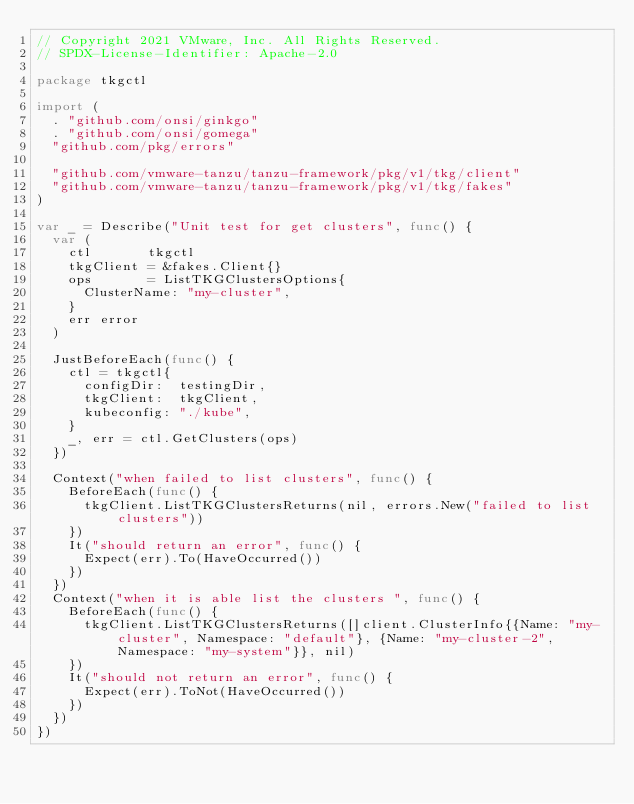<code> <loc_0><loc_0><loc_500><loc_500><_Go_>// Copyright 2021 VMware, Inc. All Rights Reserved.
// SPDX-License-Identifier: Apache-2.0

package tkgctl

import (
	. "github.com/onsi/ginkgo"
	. "github.com/onsi/gomega"
	"github.com/pkg/errors"

	"github.com/vmware-tanzu/tanzu-framework/pkg/v1/tkg/client"
	"github.com/vmware-tanzu/tanzu-framework/pkg/v1/tkg/fakes"
)

var _ = Describe("Unit test for get clusters", func() {
	var (
		ctl       tkgctl
		tkgClient = &fakes.Client{}
		ops       = ListTKGClustersOptions{
			ClusterName: "my-cluster",
		}
		err error
	)

	JustBeforeEach(func() {
		ctl = tkgctl{
			configDir:  testingDir,
			tkgClient:  tkgClient,
			kubeconfig: "./kube",
		}
		_, err = ctl.GetClusters(ops)
	})

	Context("when failed to list clusters", func() {
		BeforeEach(func() {
			tkgClient.ListTKGClustersReturns(nil, errors.New("failed to list clusters"))
		})
		It("should return an error", func() {
			Expect(err).To(HaveOccurred())
		})
	})
	Context("when it is able list the clusters ", func() {
		BeforeEach(func() {
			tkgClient.ListTKGClustersReturns([]client.ClusterInfo{{Name: "my-cluster", Namespace: "default"}, {Name: "my-cluster-2", Namespace: "my-system"}}, nil)
		})
		It("should not return an error", func() {
			Expect(err).ToNot(HaveOccurred())
		})
	})
})
</code> 